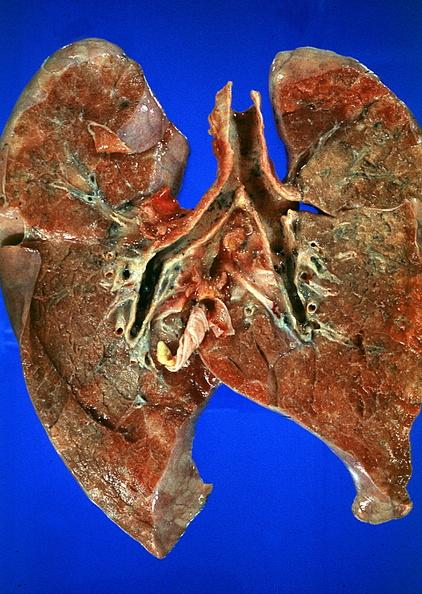s respiratory present?
Answer the question using a single word or phrase. Yes 